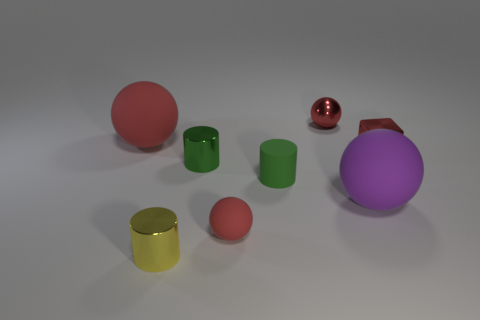There is a thing that is the same size as the purple ball; what is its color?
Provide a succinct answer. Red. Are any green matte cylinders visible?
Make the answer very short. Yes. What shape is the small red metallic object that is in front of the large red rubber thing?
Give a very brief answer. Cube. What number of objects are both left of the green shiny thing and in front of the green metallic cylinder?
Provide a short and direct response. 1. Are there any red objects that have the same material as the purple thing?
Provide a short and direct response. Yes. There is a metallic cube that is the same color as the tiny shiny sphere; what size is it?
Your response must be concise. Small. How many cubes are either small rubber objects or matte objects?
Your answer should be very brief. 0. The yellow object is what size?
Your answer should be very brief. Small. There is a green shiny cylinder; what number of matte balls are left of it?
Ensure brevity in your answer.  1. There is a matte object that is in front of the big rubber ball that is in front of the tiny metal block; how big is it?
Make the answer very short. Small. 